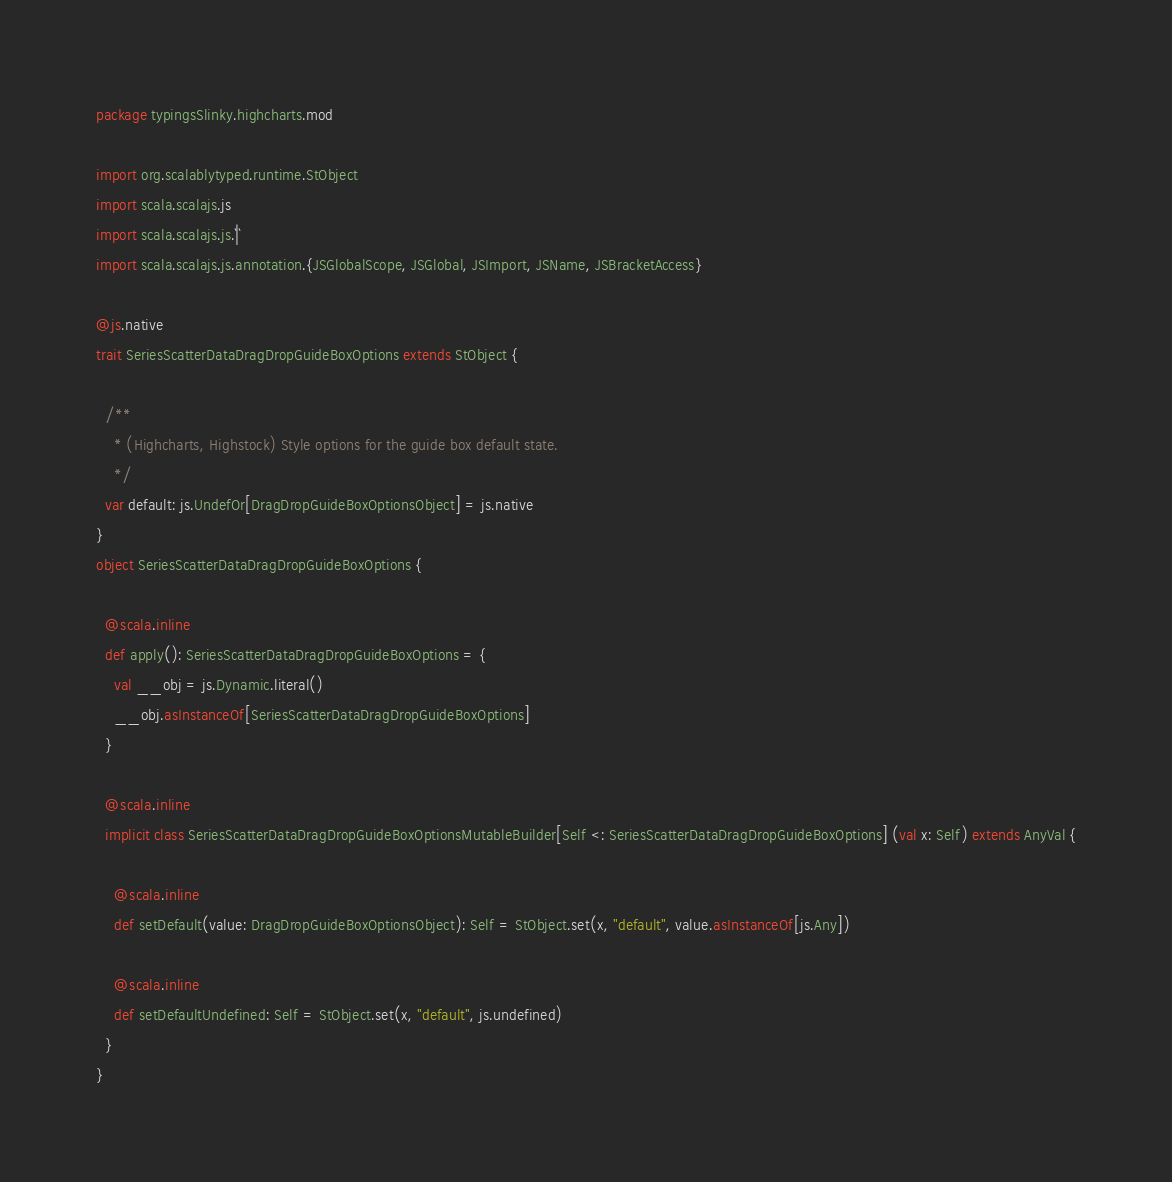<code> <loc_0><loc_0><loc_500><loc_500><_Scala_>package typingsSlinky.highcharts.mod

import org.scalablytyped.runtime.StObject
import scala.scalajs.js
import scala.scalajs.js.`|`
import scala.scalajs.js.annotation.{JSGlobalScope, JSGlobal, JSImport, JSName, JSBracketAccess}

@js.native
trait SeriesScatterDataDragDropGuideBoxOptions extends StObject {
  
  /**
    * (Highcharts, Highstock) Style options for the guide box default state.
    */
  var default: js.UndefOr[DragDropGuideBoxOptionsObject] = js.native
}
object SeriesScatterDataDragDropGuideBoxOptions {
  
  @scala.inline
  def apply(): SeriesScatterDataDragDropGuideBoxOptions = {
    val __obj = js.Dynamic.literal()
    __obj.asInstanceOf[SeriesScatterDataDragDropGuideBoxOptions]
  }
  
  @scala.inline
  implicit class SeriesScatterDataDragDropGuideBoxOptionsMutableBuilder[Self <: SeriesScatterDataDragDropGuideBoxOptions] (val x: Self) extends AnyVal {
    
    @scala.inline
    def setDefault(value: DragDropGuideBoxOptionsObject): Self = StObject.set(x, "default", value.asInstanceOf[js.Any])
    
    @scala.inline
    def setDefaultUndefined: Self = StObject.set(x, "default", js.undefined)
  }
}
</code> 